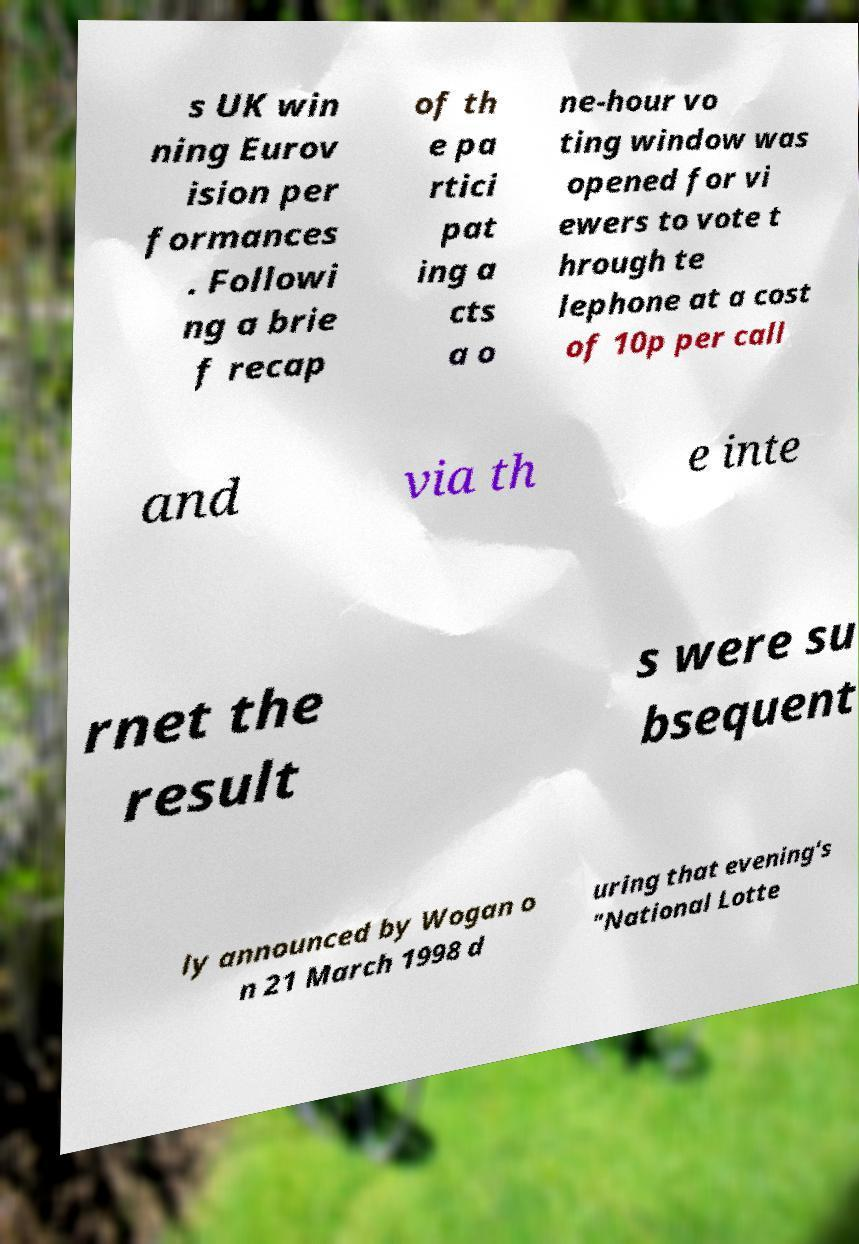Could you assist in decoding the text presented in this image and type it out clearly? s UK win ning Eurov ision per formances . Followi ng a brie f recap of th e pa rtici pat ing a cts a o ne-hour vo ting window was opened for vi ewers to vote t hrough te lephone at a cost of 10p per call and via th e inte rnet the result s were su bsequent ly announced by Wogan o n 21 March 1998 d uring that evening's "National Lotte 